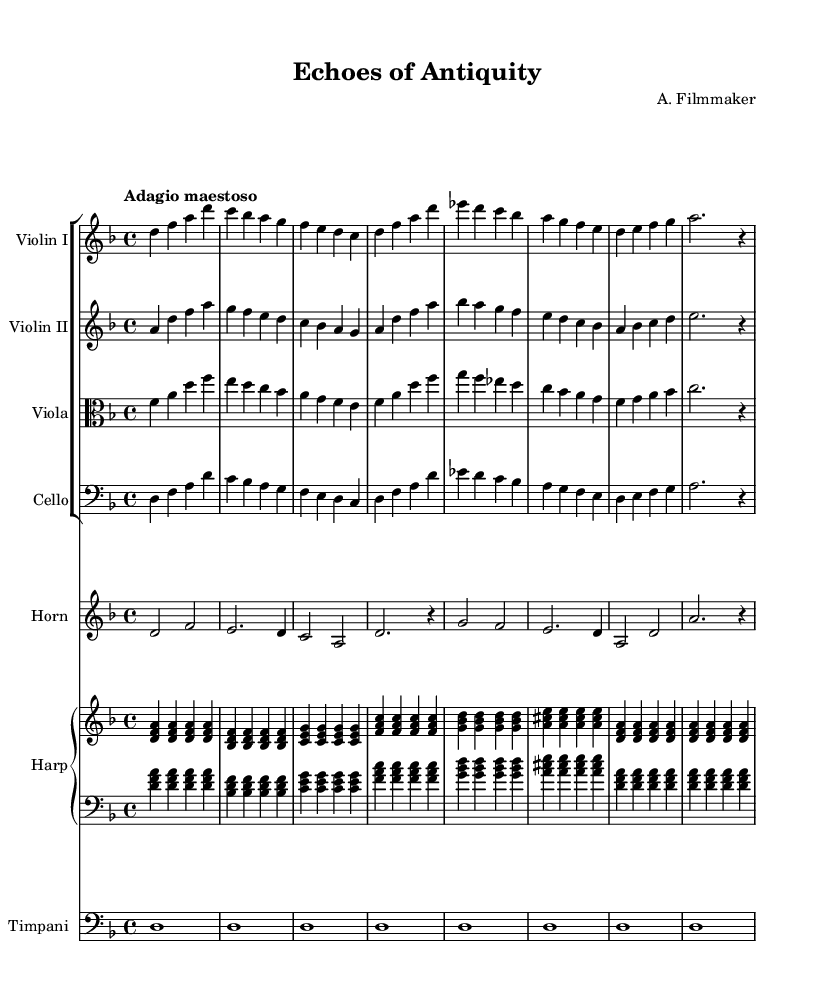What is the key signature of this music? The key signature is specified at the beginning of the score. In this piece, it features one flat (B flat), indicating that the music is in D minor.
Answer: D minor What is the time signature for this music? The time signature is displayed after the clef and shows how many beats are in each measure. Here, it is indicated as 4/4, meaning there are 4 beats in each measure.
Answer: 4/4 What tempo marking is given? The tempo marking is mentioned at the start of the piece under the global section. It describes the speed of the music, which is 'Adagio maestoso', indicating a slow and majestic feel.
Answer: Adagio maestoso Which instruments are included in the score? The instruments are listed at the beginning of their respective staves. They include Violin I, Violin II, Viola, Cello, Horn, Harp, and Timpani, reflecting a rich orchestral arrangement.
Answer: Violin I, Violin II, Viola, Cello, Horn, Harp, Timpani How many measures are there in the first system (staff)? To find the number of measures, count the vertical bar lines that separate the measures. In the first staff, there are four measures present.
Answer: Four Which instrument plays the lowest notes in this arrangement? The instrument that plays in the bass clef traditionally plays the lowest notes. In this score, the Cello section is indicated as playing in the bass clef, thus producing the lowest pitches in the orchestration.
Answer: Cello What is the significance of the use of timpani in this score? Timpani adds dramatic depth to orchestral music, particularly in film scores, often signaling shifts in mood or emphasizing climactic moments. In this piece, the use of timpani contributes to the epic and grand atmosphere appropriate for a historical film setting.
Answer: Dramatic depth 